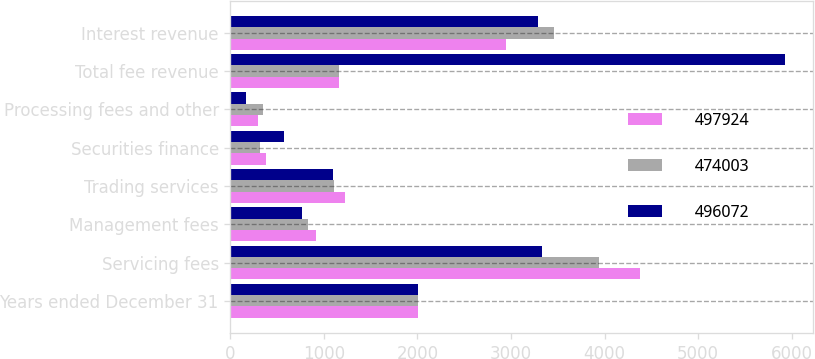Convert chart. <chart><loc_0><loc_0><loc_500><loc_500><stacked_bar_chart><ecel><fcel>Years ended December 31<fcel>Servicing fees<fcel>Management fees<fcel>Trading services<fcel>Securities finance<fcel>Processing fees and other<fcel>Total fee revenue<fcel>Interest revenue<nl><fcel>497924<fcel>2011<fcel>4382<fcel>917<fcel>1220<fcel>378<fcel>297<fcel>1163<fcel>2946<nl><fcel>474003<fcel>2010<fcel>3938<fcel>829<fcel>1106<fcel>318<fcel>349<fcel>1163<fcel>3462<nl><fcel>496072<fcel>2009<fcel>3334<fcel>766<fcel>1094<fcel>570<fcel>171<fcel>5935<fcel>3286<nl></chart> 